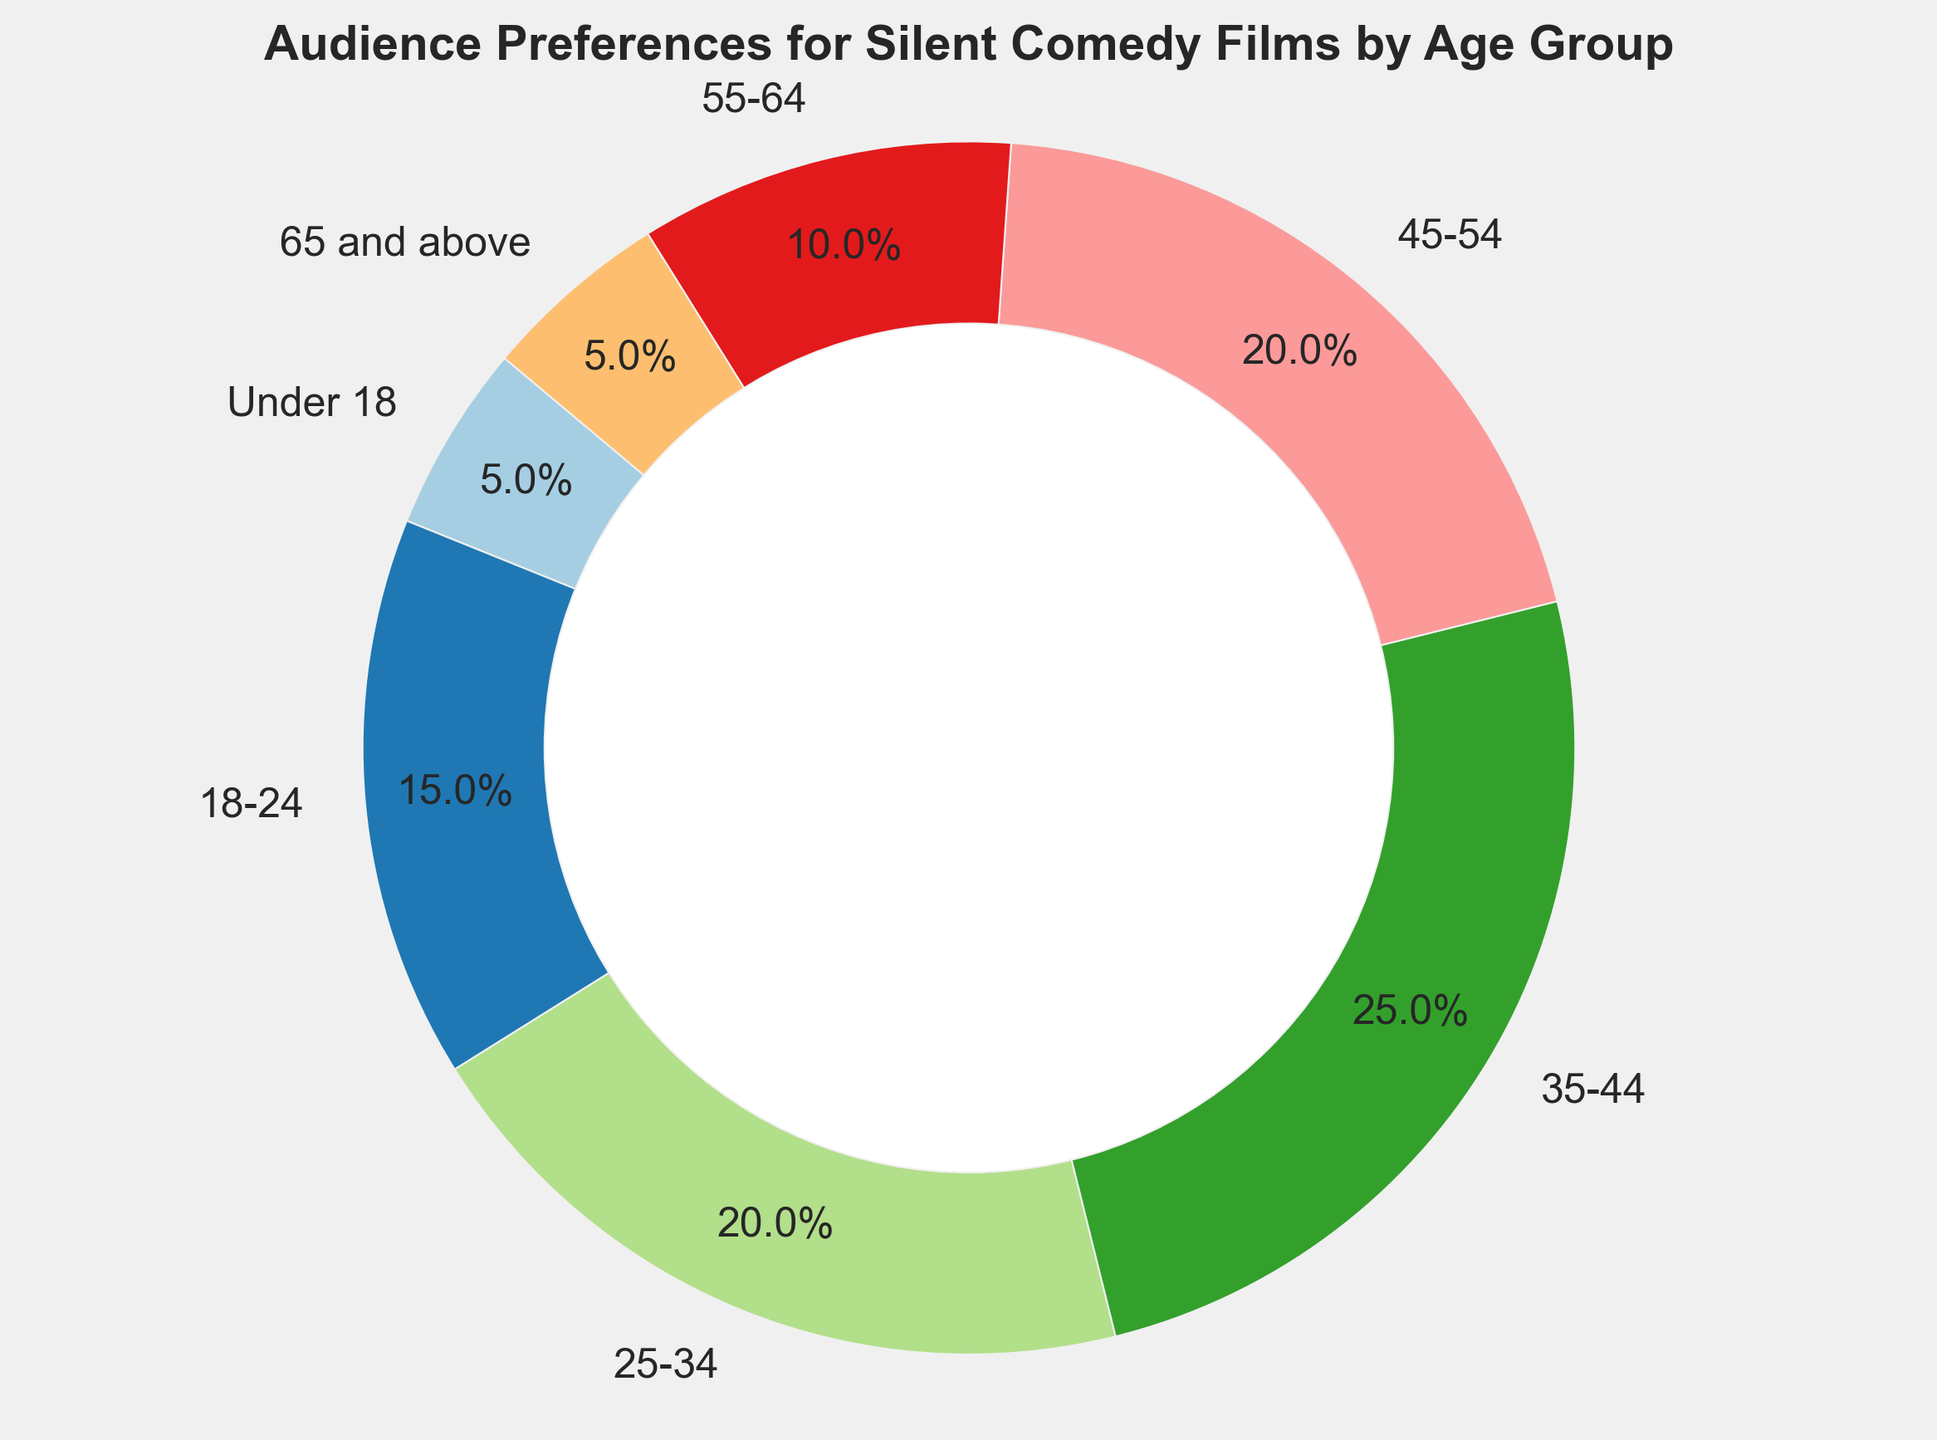What's the largest age group interested in silent comedy films? The age group 35-44 has the highest percentage in the pie chart, indicating the largest interest.
Answer: 35-44 What's the combined percentage of interest for the under 18 and 65 and above age groups? The under 18 group has 5% interest, and the 65 and above group also has 5% interest. Their combined interest is 5% + 5% = 10%.
Answer: 10% Which age groups have the same percentage of interest? Both the under 18 group and the 65 and above group each have a 5% interest. Similarly, the 25-34 and 45-54 age groups each have a 20% interest.
Answer: Under 18 & 65 and above, 25-34 & 45-54 Which age group has a lower interest than the 55-64 group? The 55-64 group has a 10% interest. The groups with lower interest are the under 18 group with 5% and the 65 and above group also with 5%.
Answer: Under 18 and 65 and above What is the total percentage of the age groups that have an interest of 20% or more? The age groups 25-34, 35-44, and 45-54 have interests of 20%, 25%, and 20% respectively. Summing these up gives 20% + 25% + 20% = 65%.
Answer: 65% Which age group has the smallest visual slice in the pie chart? The under 18 and 65 and above age groups each have the smallest slice, as they both represent 5%.
Answer: Under 18 and 65 and above What is the difference in interest percentage between the age groups 18-24 and 35-44? The interest percentage for the 18-24 group is 15%, and for the 35-44 group, it is 25%. The difference is 25% - 15% = 10%.
Answer: 10% How many age groups have an interest of 10% or more? The age groups with 10% or more interest are 18-24, 25-34, 35-44, 45-54, and 55-64. This makes a total of 5 age groups.
Answer: 5 